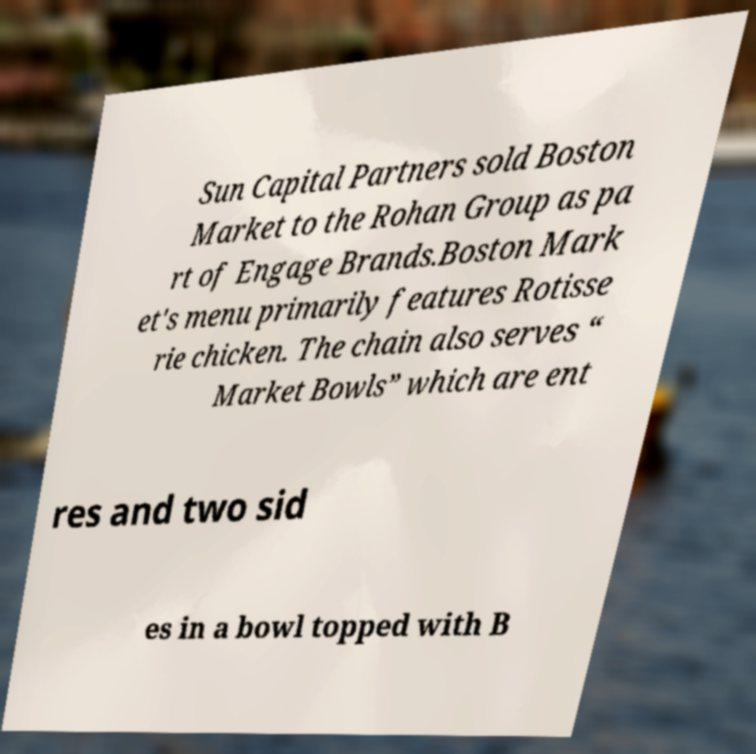Can you accurately transcribe the text from the provided image for me? Sun Capital Partners sold Boston Market to the Rohan Group as pa rt of Engage Brands.Boston Mark et's menu primarily features Rotisse rie chicken. The chain also serves “ Market Bowls” which are ent res and two sid es in a bowl topped with B 